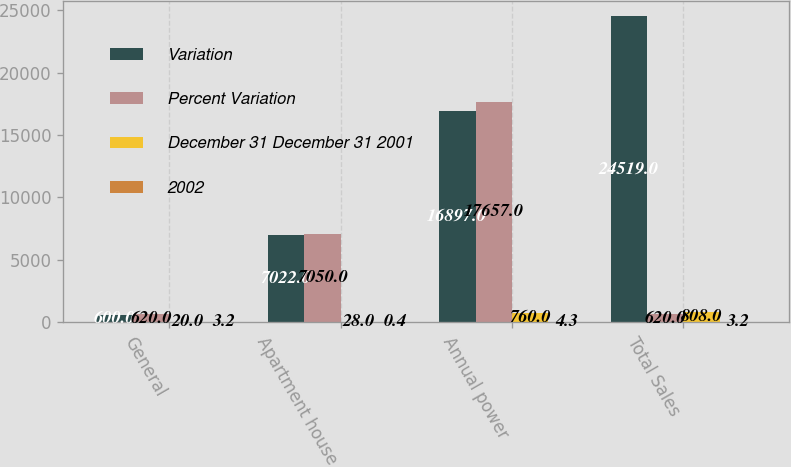Convert chart. <chart><loc_0><loc_0><loc_500><loc_500><stacked_bar_chart><ecel><fcel>General<fcel>Apartment house<fcel>Annual power<fcel>Total Sales<nl><fcel>Variation<fcel>600<fcel>7022<fcel>16897<fcel>24519<nl><fcel>Percent Variation<fcel>620<fcel>7050<fcel>17657<fcel>620<nl><fcel>December 31 December 31 2001<fcel>20<fcel>28<fcel>760<fcel>808<nl><fcel>2002<fcel>3.2<fcel>0.4<fcel>4.3<fcel>3.2<nl></chart> 